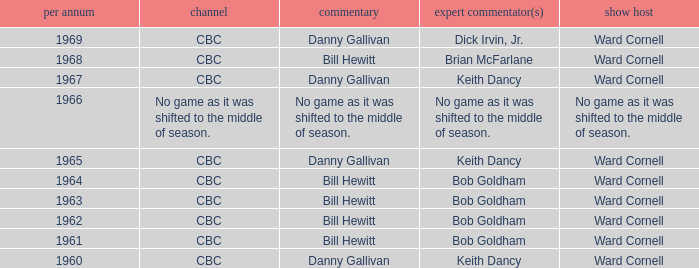Who gave the play by play commentary with studio host Ward Cornell? Danny Gallivan, Bill Hewitt, Danny Gallivan, Danny Gallivan, Bill Hewitt, Bill Hewitt, Bill Hewitt, Bill Hewitt, Danny Gallivan. 